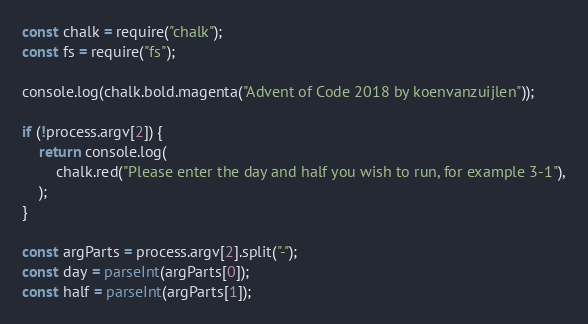Convert code to text. <code><loc_0><loc_0><loc_500><loc_500><_JavaScript_>const chalk = require("chalk");
const fs = require("fs");

console.log(chalk.bold.magenta("Advent of Code 2018 by koenvanzuijlen"));

if (!process.argv[2]) {
	return console.log(
		chalk.red("Please enter the day and half you wish to run, for example 3-1"),
	);
}

const argParts = process.argv[2].split("-");
const day = parseInt(argParts[0]);
const half = parseInt(argParts[1]);</code> 